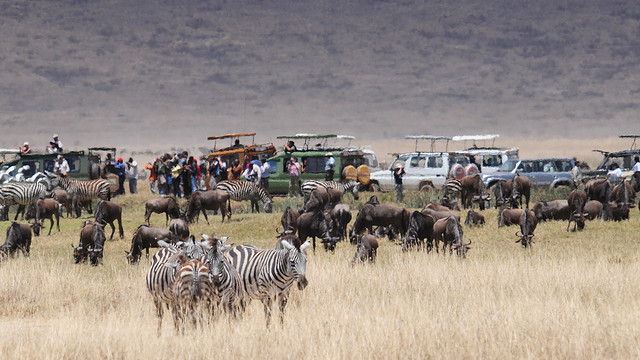What kind of animals are predominately seen in the foreground? The animals that primarily occupy the foreground of the image are zebras, easily identifiable by their distinctive black and white striped coats, and wildebeests, recognized by their grayish-brown fur and curved horns. 